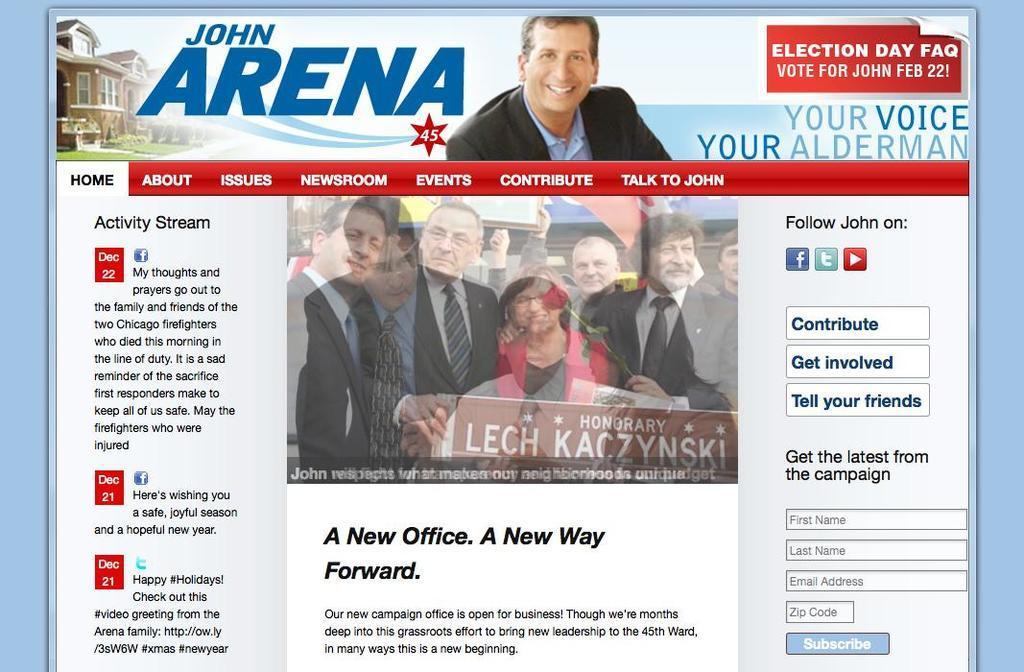Could you give a brief overview of what you see in this image? It's a digital page, on this man is smiling, he wore a coat and few other people are there. 